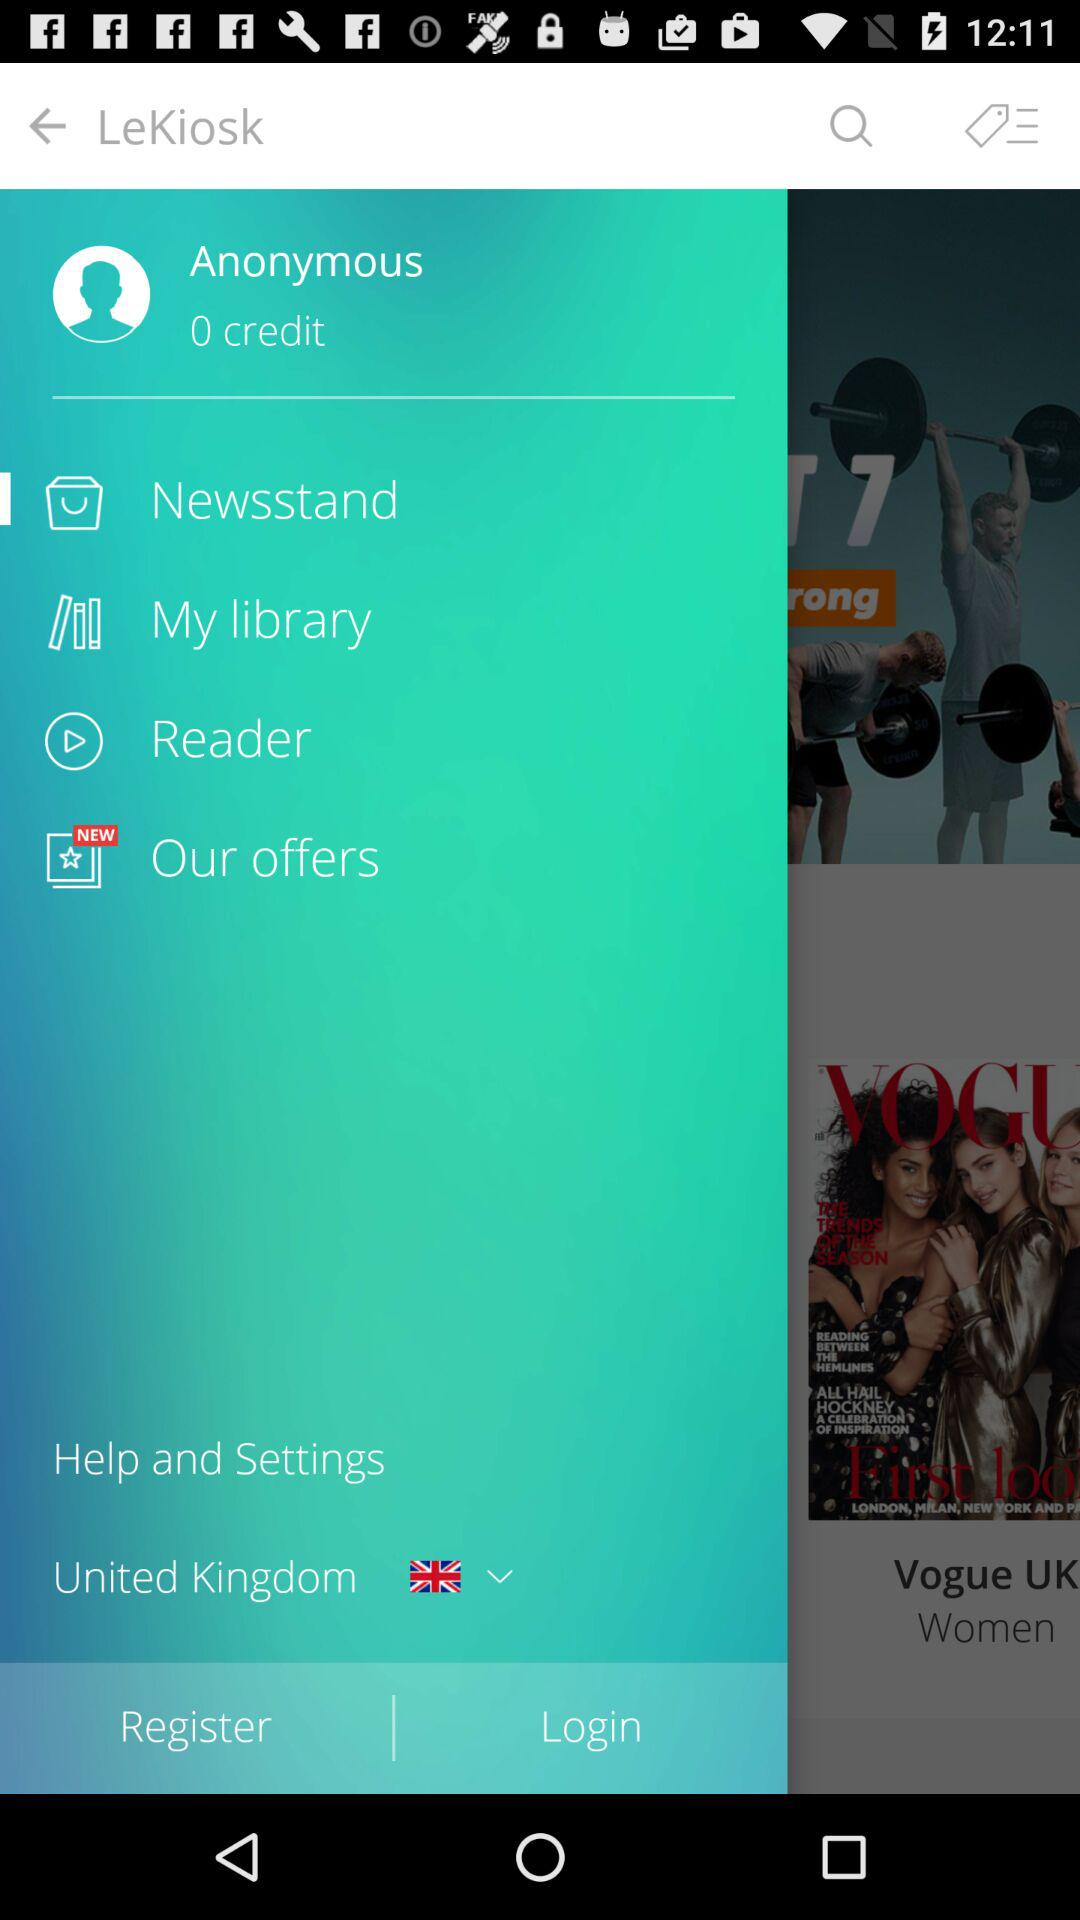What is the name of the user? The name of the user is Anonymous. 